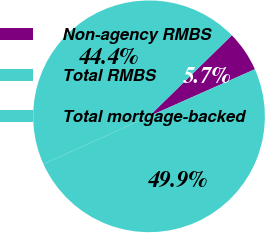<chart> <loc_0><loc_0><loc_500><loc_500><pie_chart><fcel>Non-agency RMBS<fcel>Total RMBS<fcel>Total mortgage-backed<nl><fcel>5.67%<fcel>44.42%<fcel>49.91%<nl></chart> 